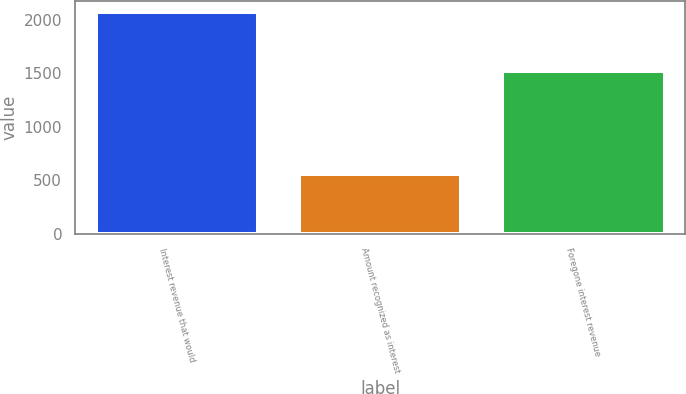Convert chart. <chart><loc_0><loc_0><loc_500><loc_500><bar_chart><fcel>Interest revenue that would<fcel>Amount recognized as interest<fcel>Foregone interest revenue<nl><fcel>2072<fcel>553<fcel>1519<nl></chart> 